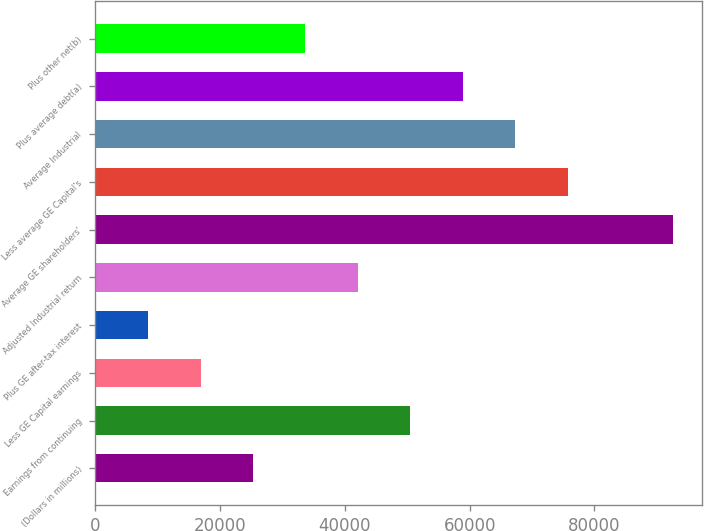Convert chart to OTSL. <chart><loc_0><loc_0><loc_500><loc_500><bar_chart><fcel>(Dollars in millions)<fcel>Earnings from continuing<fcel>Less GE Capital earnings<fcel>Plus GE after-tax interest<fcel>Adjusted Industrial return<fcel>Average GE shareholders'<fcel>Less average GE Capital's<fcel>Average Industrial<fcel>Plus average debt(a)<fcel>Plus other net(b)<nl><fcel>25258.3<fcel>50501.5<fcel>16844<fcel>8429.58<fcel>42087.1<fcel>92573.4<fcel>75744.6<fcel>67330.2<fcel>58915.9<fcel>33672.7<nl></chart> 